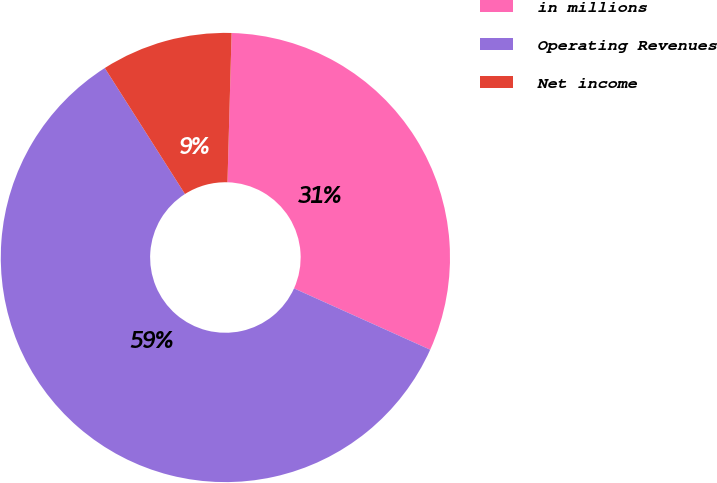Convert chart. <chart><loc_0><loc_0><loc_500><loc_500><pie_chart><fcel>in millions<fcel>Operating Revenues<fcel>Net income<nl><fcel>31.29%<fcel>59.24%<fcel>9.46%<nl></chart> 